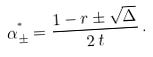<formula> <loc_0><loc_0><loc_500><loc_500>\alpha _ { \pm } ^ { ^ { * } } = \frac { 1 - r \pm \sqrt { \Delta } } { 2 \, t } \, .</formula> 